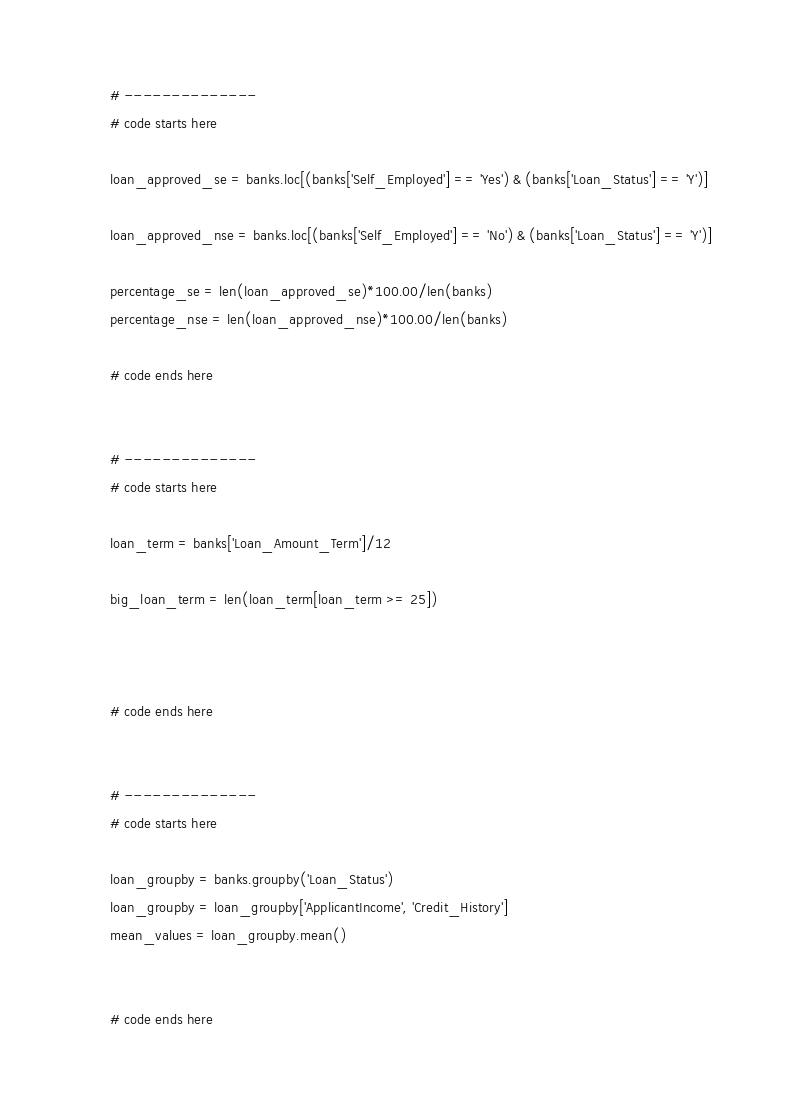<code> <loc_0><loc_0><loc_500><loc_500><_Python_>
# --------------
# code starts here

loan_approved_se = banks.loc[(banks['Self_Employed'] == 'Yes') & (banks['Loan_Status'] == 'Y')]

loan_approved_nse = banks.loc[(banks['Self_Employed'] == 'No') & (banks['Loan_Status'] == 'Y')]

percentage_se = len(loan_approved_se)*100.00/len(banks)
percentage_nse = len(loan_approved_nse)*100.00/len(banks)

# code ends here


# --------------
# code starts here

loan_term = banks['Loan_Amount_Term']/12

big_loan_term = len(loan_term[loan_term >= 25])



# code ends here


# --------------
# code starts here

loan_groupby = banks.groupby('Loan_Status')
loan_groupby = loan_groupby['ApplicantIncome', 'Credit_History']
mean_values = loan_groupby.mean()


# code ends here


</code> 